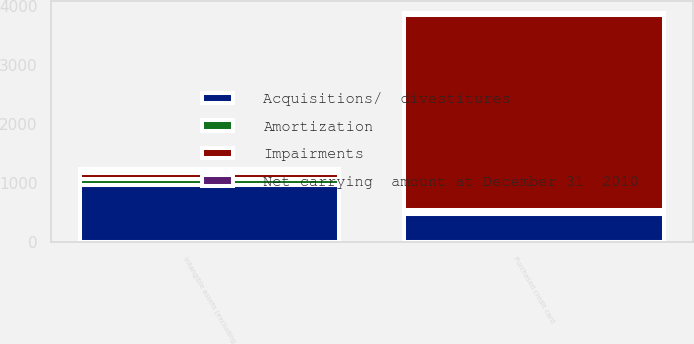<chart> <loc_0><loc_0><loc_500><loc_500><stacked_bar_chart><ecel><fcel>Purchased credit card<fcel>Intangible assets (excluding<nl><fcel>Impairments<fcel>3310<fcel>99<nl><fcel>Amortization<fcel>53<fcel>99<nl><fcel>Acquisitions/  divestitures<fcel>486<fcel>976<nl><fcel>Net carrying  amount at December 31  2010<fcel>39<fcel>71<nl></chart> 